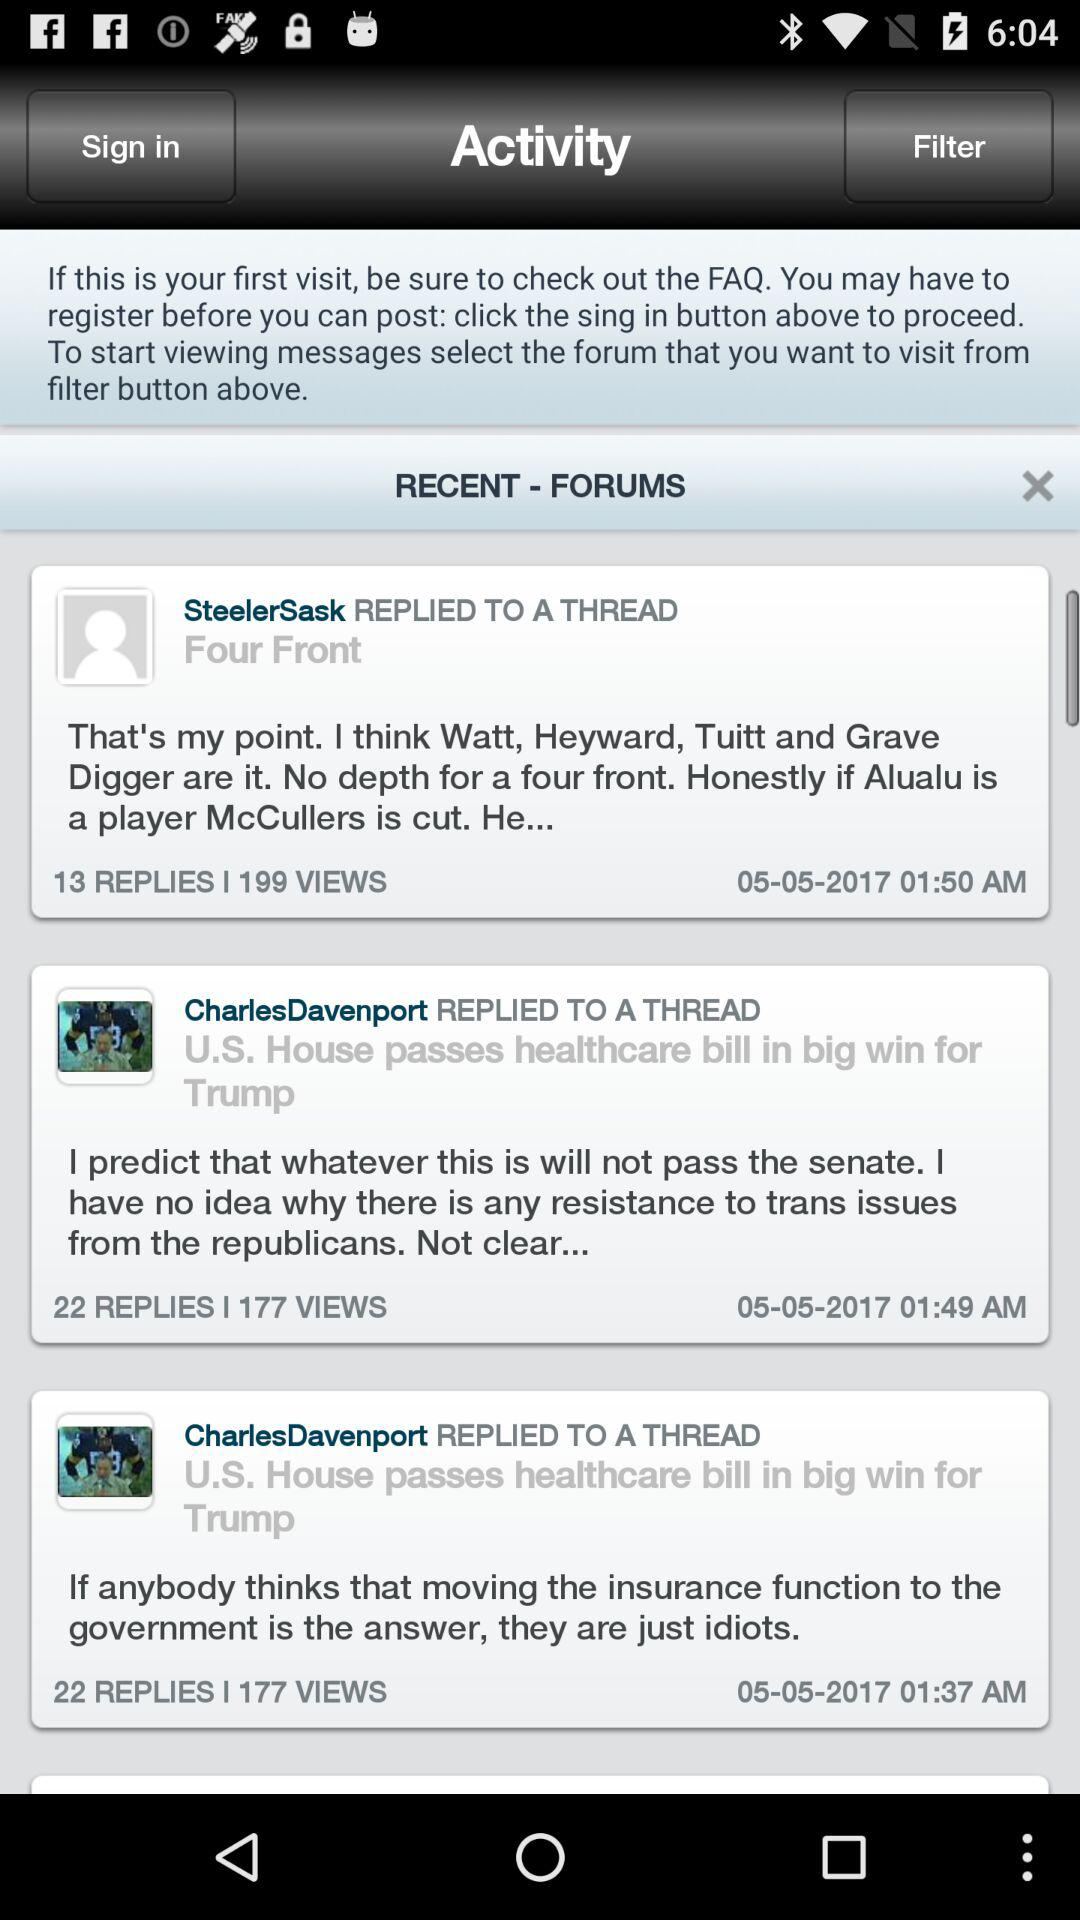At what time did "SteelerSask" reply to a thread? "SteelerSask" replied to a thread at 01:50 AM. 